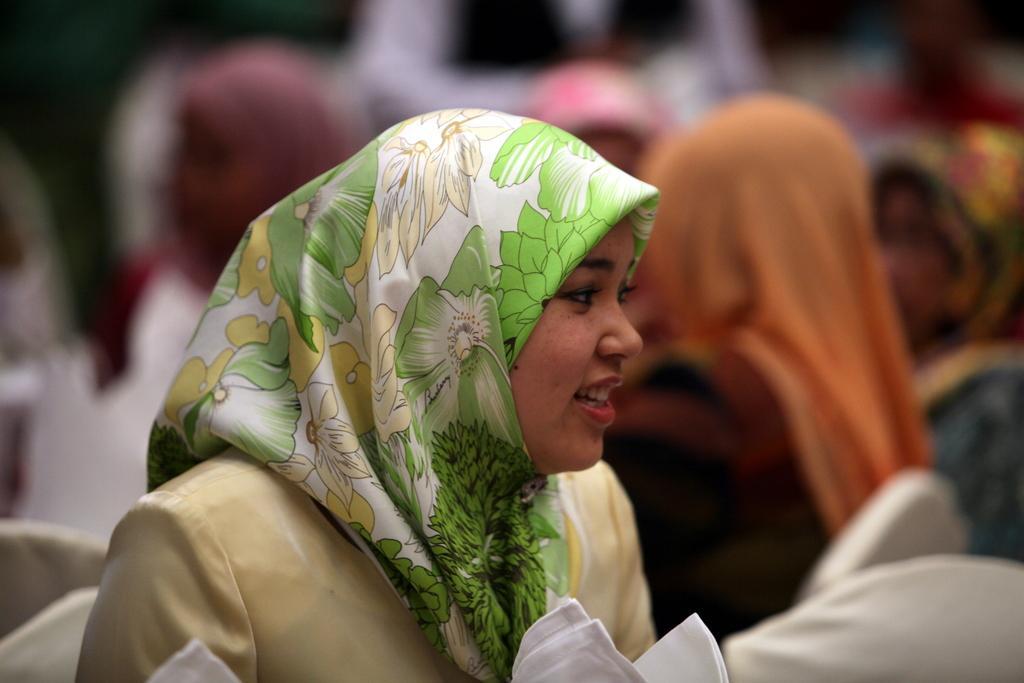In one or two sentences, can you explain what this image depicts? In this image, we can see a woman is smiling and wearing a scarf on her head. At the we can see few white clothes. Background there is a blur view. Here we can see few people. 